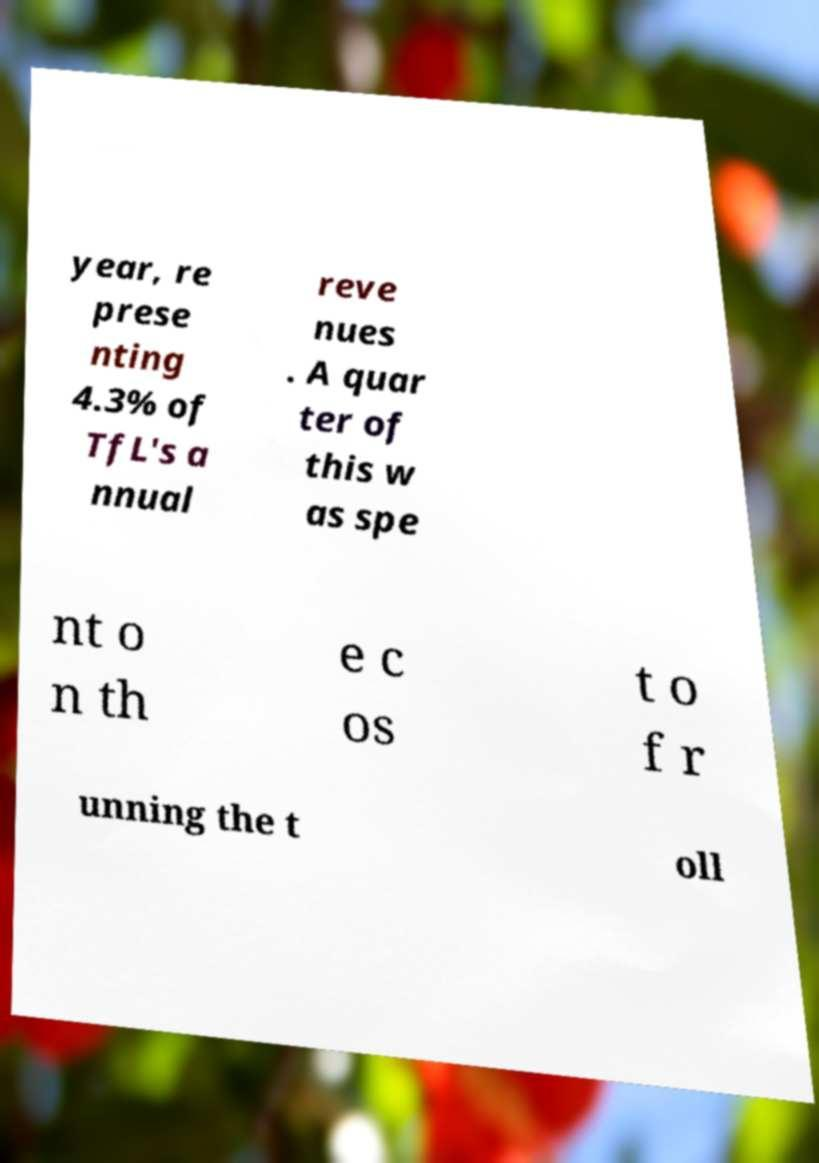What messages or text are displayed in this image? I need them in a readable, typed format. year, re prese nting 4.3% of TfL's a nnual reve nues . A quar ter of this w as spe nt o n th e c os t o f r unning the t oll 